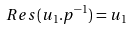<formula> <loc_0><loc_0><loc_500><loc_500>R e s ( u _ { 1 } . p ^ { - 1 } ) = u _ { 1 }</formula> 